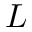<formula> <loc_0><loc_0><loc_500><loc_500>L</formula> 